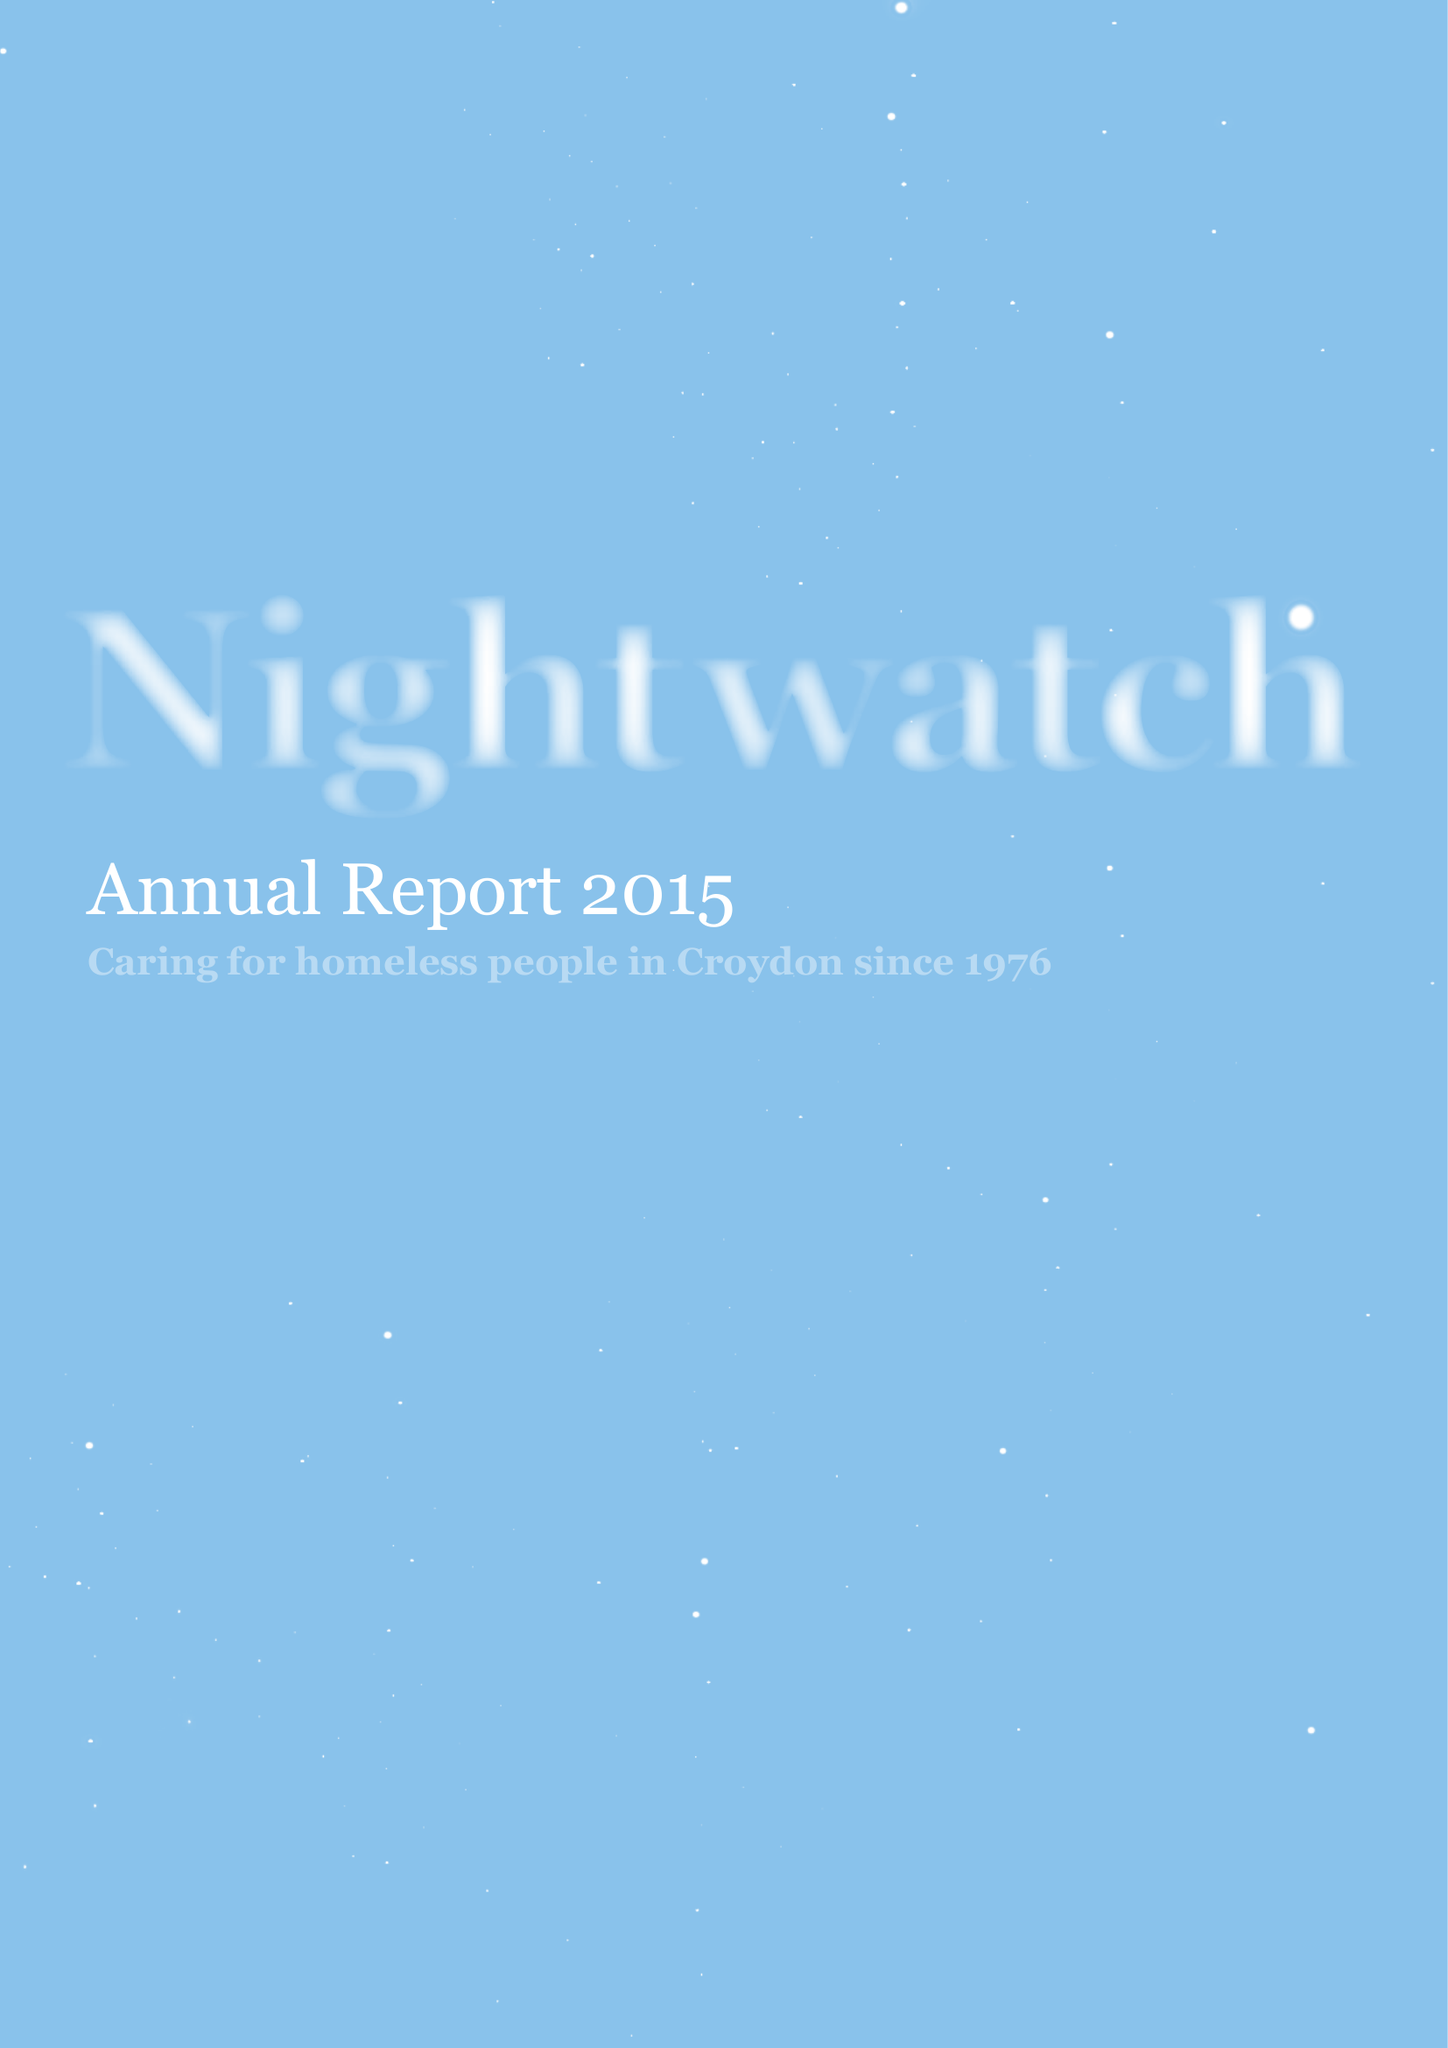What is the value for the charity_number?
Answer the question using a single word or phrase. 274925 